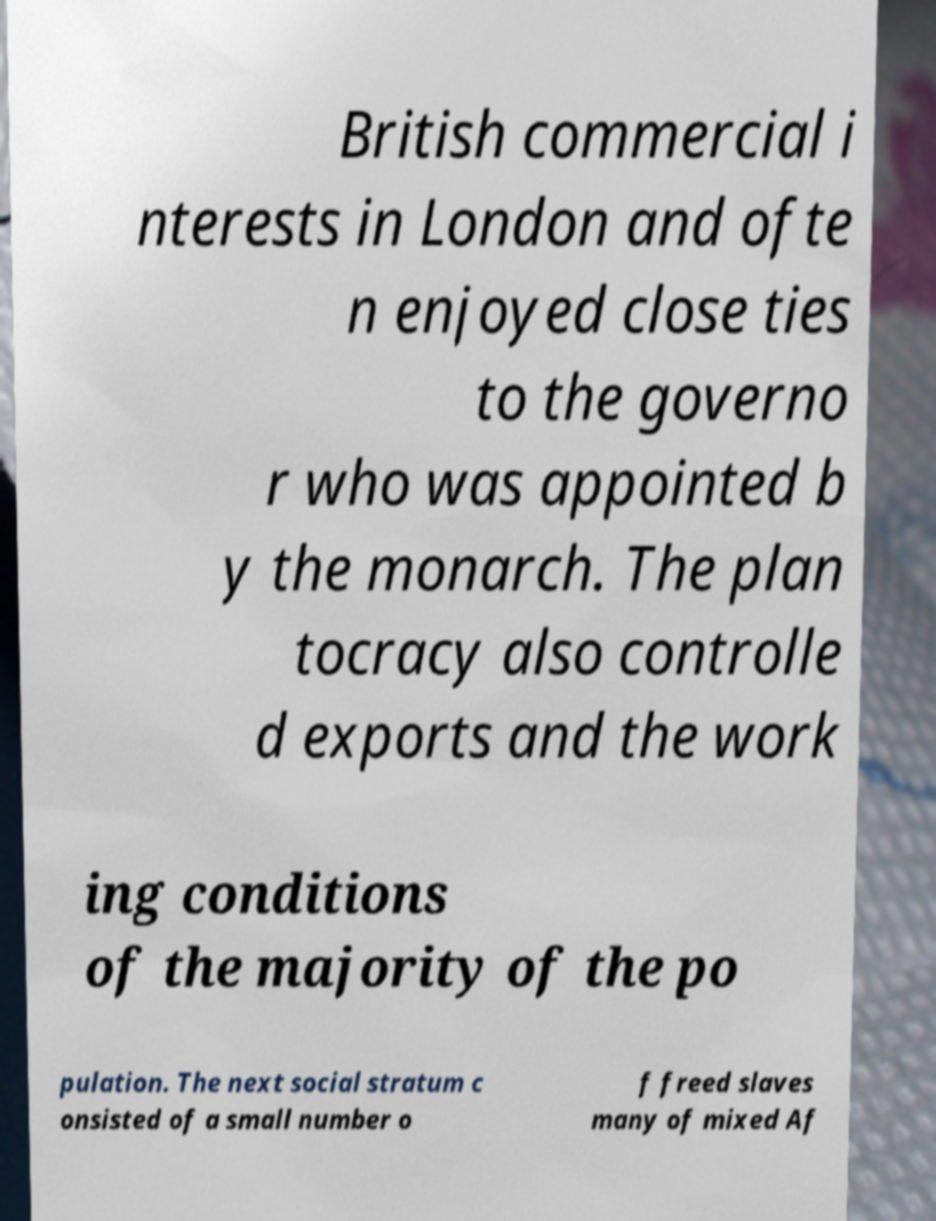I need the written content from this picture converted into text. Can you do that? British commercial i nterests in London and ofte n enjoyed close ties to the governo r who was appointed b y the monarch. The plan tocracy also controlle d exports and the work ing conditions of the majority of the po pulation. The next social stratum c onsisted of a small number o f freed slaves many of mixed Af 